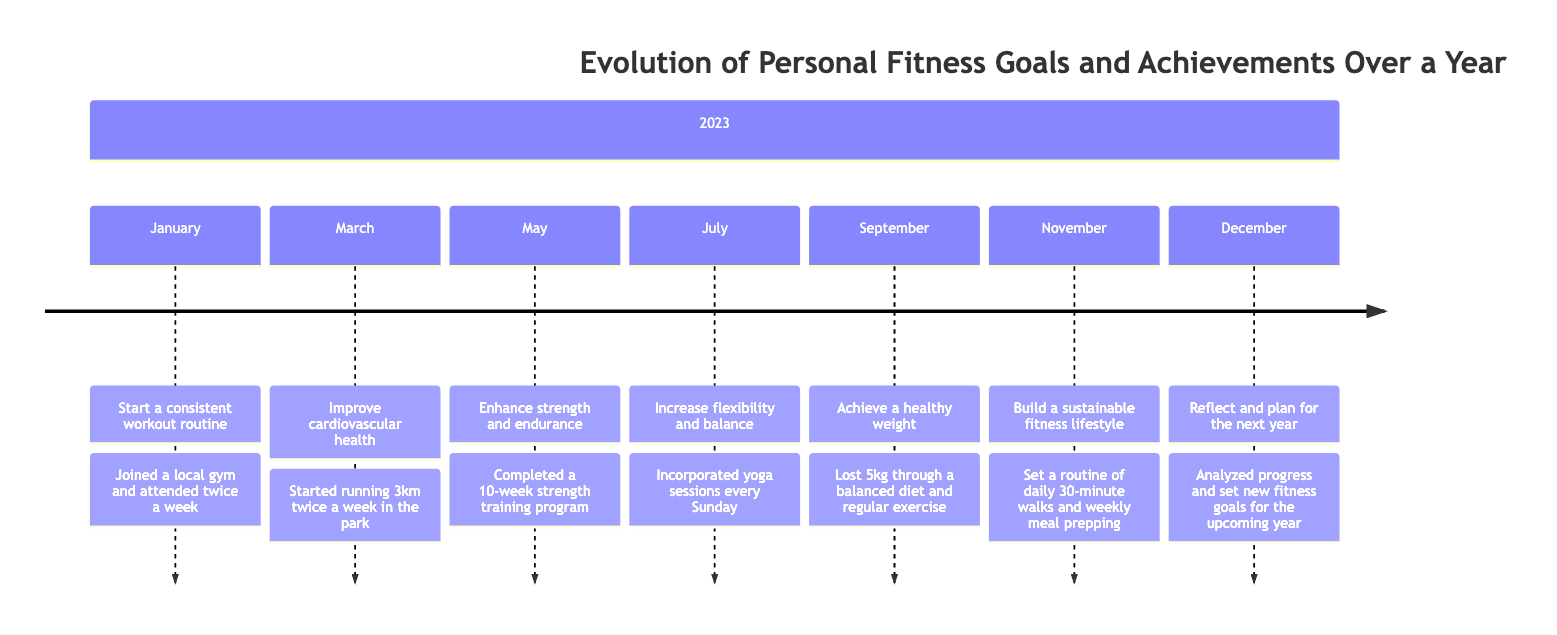What was the first goal achieved in the year? According to the timeline, the first goal listed is "Start a consistent workout routine," achieved by joining a local gym and attending twice a week.
Answer: Start a consistent workout routine How many goals were set in total? There are seven specific goals outlined in the timeline, one for each specified month from January to December.
Answer: 7 What was the achievement in July? In July, the goal was "Increase flexibility and balance," and the achievement was incorporating yoga sessions every Sunday.
Answer: Incorporated yoga sessions every Sunday Which month focused on achieving a healthy weight? The month that focused on achieving a healthy weight is September, with the associated goal and achievement of losing 5kg through a balanced diet and regular exercise.
Answer: September What was the goal set in March? The goal set in March was "Improve cardiovascular health," which was achieved by starting to run 3km twice a week in the park.
Answer: Improve cardiovascular health What are the key components of the achievement in November? The achievement in November included building a sustainable fitness lifestyle, which involved setting a routine of daily 30-minute walks and weekly meal prepping. Therefore, the key components are daily walks and meal prepping.
Answer: Daily 30-minute walks and weekly meal prepping Which goal was achieved right before reflecting for the next year? The last goal before reflecting for the next year was to "Build a sustainable fitness lifestyle" achieved in November.
Answer: Build a sustainable fitness lifestyle What type of exercise was primarily focused on in May? In May, the focus was on enhancing strength and endurance, which was achieved through completing a 10-week strength training program.
Answer: Strength training In which month was flexibility and balance addressed? Flexibility and balance were addressed in July, as indicated by the goal for that month.
Answer: July 